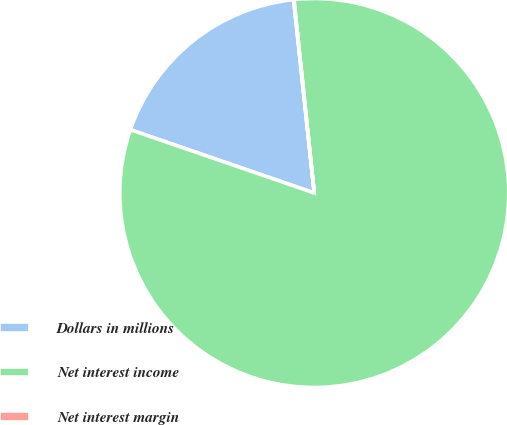Convert chart to OTSL. <chart><loc_0><loc_0><loc_500><loc_500><pie_chart><fcel>Dollars in millions<fcel>Net interest income<fcel>Net interest margin<nl><fcel>18.03%<fcel>81.94%<fcel>0.03%<nl></chart> 